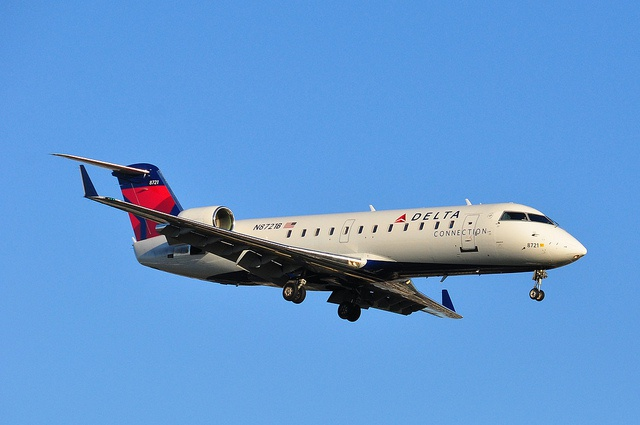Describe the objects in this image and their specific colors. I can see a airplane in gray, black, tan, and beige tones in this image. 